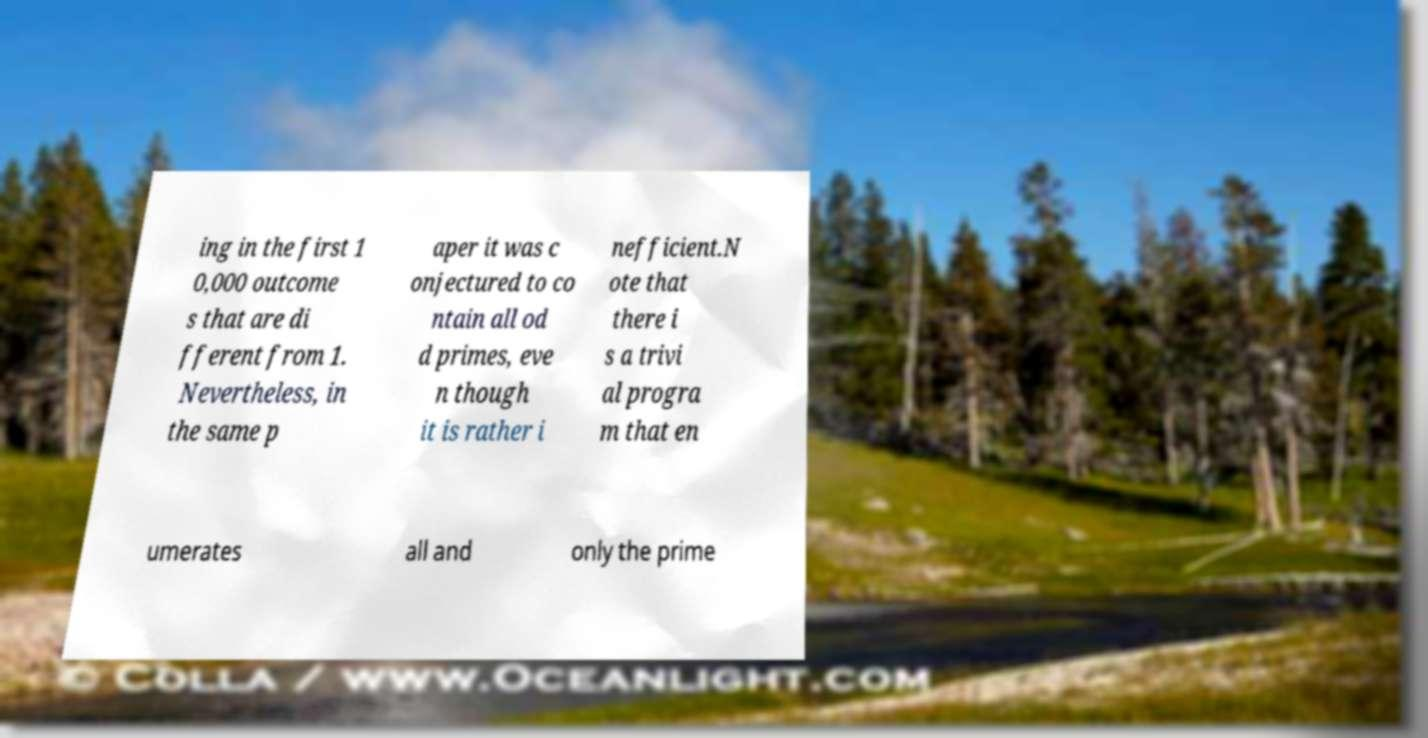Could you assist in decoding the text presented in this image and type it out clearly? ing in the first 1 0,000 outcome s that are di fferent from 1. Nevertheless, in the same p aper it was c onjectured to co ntain all od d primes, eve n though it is rather i nefficient.N ote that there i s a trivi al progra m that en umerates all and only the prime 